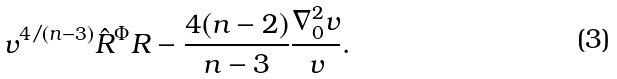<formula> <loc_0><loc_0><loc_500><loc_500>v ^ { 4 / ( n - 3 ) } \hat { R } ^ { \Phi } R - \frac { 4 ( n - 2 ) } { n - 3 } \frac { \nabla _ { 0 } ^ { 2 } v } { v } .</formula> 